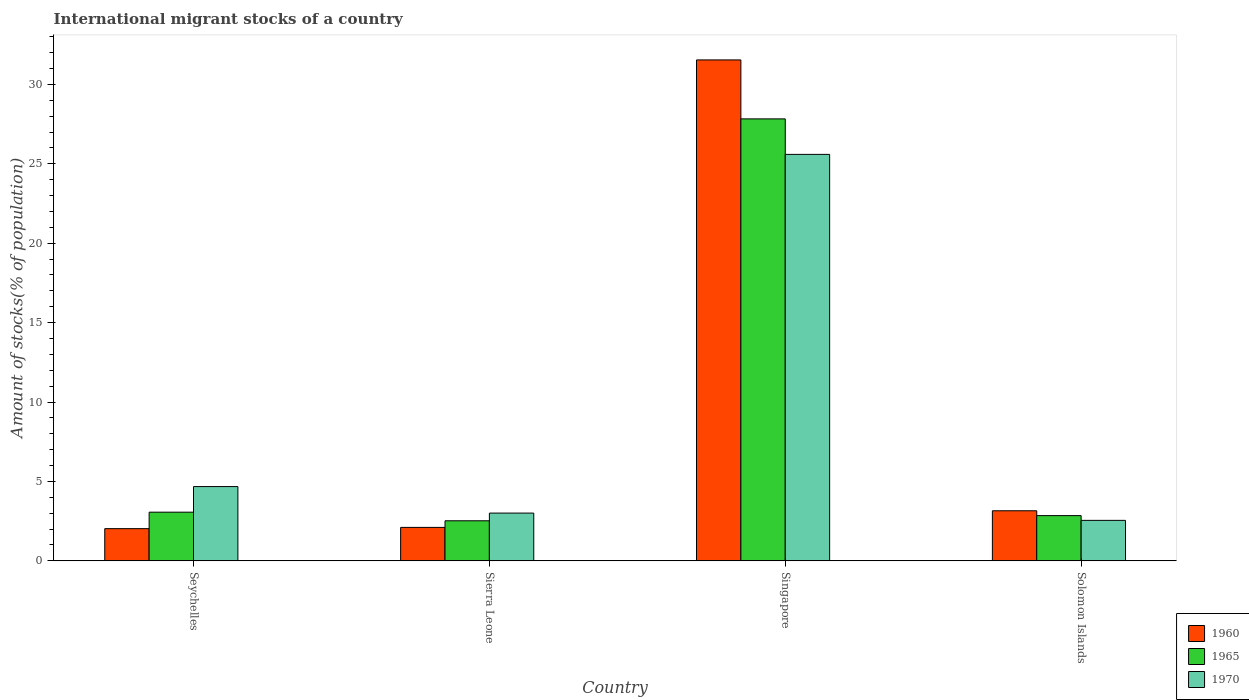How many different coloured bars are there?
Provide a short and direct response. 3. Are the number of bars per tick equal to the number of legend labels?
Keep it short and to the point. Yes. How many bars are there on the 3rd tick from the left?
Ensure brevity in your answer.  3. How many bars are there on the 4th tick from the right?
Keep it short and to the point. 3. What is the label of the 2nd group of bars from the left?
Ensure brevity in your answer.  Sierra Leone. What is the amount of stocks in in 1965 in Solomon Islands?
Provide a succinct answer. 2.85. Across all countries, what is the maximum amount of stocks in in 1970?
Ensure brevity in your answer.  25.59. Across all countries, what is the minimum amount of stocks in in 1970?
Your answer should be compact. 2.55. In which country was the amount of stocks in in 1965 maximum?
Your response must be concise. Singapore. In which country was the amount of stocks in in 1970 minimum?
Provide a succinct answer. Solomon Islands. What is the total amount of stocks in in 1960 in the graph?
Offer a very short reply. 38.82. What is the difference between the amount of stocks in in 1965 in Sierra Leone and that in Singapore?
Provide a succinct answer. -25.31. What is the difference between the amount of stocks in in 1970 in Solomon Islands and the amount of stocks in in 1965 in Singapore?
Make the answer very short. -25.28. What is the average amount of stocks in in 1970 per country?
Provide a short and direct response. 8.95. What is the difference between the amount of stocks in of/in 1960 and amount of stocks in of/in 1970 in Solomon Islands?
Provide a short and direct response. 0.6. What is the ratio of the amount of stocks in in 1970 in Singapore to that in Solomon Islands?
Your answer should be very brief. 10.04. What is the difference between the highest and the second highest amount of stocks in in 1970?
Keep it short and to the point. 22.58. What is the difference between the highest and the lowest amount of stocks in in 1965?
Keep it short and to the point. 25.31. Is it the case that in every country, the sum of the amount of stocks in in 1965 and amount of stocks in in 1960 is greater than the amount of stocks in in 1970?
Make the answer very short. Yes. What is the difference between two consecutive major ticks on the Y-axis?
Offer a terse response. 5. Are the values on the major ticks of Y-axis written in scientific E-notation?
Your answer should be very brief. No. Does the graph contain any zero values?
Offer a very short reply. No. How many legend labels are there?
Your response must be concise. 3. How are the legend labels stacked?
Make the answer very short. Vertical. What is the title of the graph?
Provide a succinct answer. International migrant stocks of a country. What is the label or title of the Y-axis?
Your answer should be very brief. Amount of stocks(% of population). What is the Amount of stocks(% of population) of 1960 in Seychelles?
Provide a succinct answer. 2.03. What is the Amount of stocks(% of population) in 1965 in Seychelles?
Your answer should be very brief. 3.06. What is the Amount of stocks(% of population) in 1970 in Seychelles?
Your answer should be very brief. 4.68. What is the Amount of stocks(% of population) of 1960 in Sierra Leone?
Keep it short and to the point. 2.1. What is the Amount of stocks(% of population) in 1965 in Sierra Leone?
Give a very brief answer. 2.52. What is the Amount of stocks(% of population) in 1970 in Sierra Leone?
Offer a very short reply. 3.01. What is the Amount of stocks(% of population) in 1960 in Singapore?
Your answer should be very brief. 31.54. What is the Amount of stocks(% of population) in 1965 in Singapore?
Ensure brevity in your answer.  27.83. What is the Amount of stocks(% of population) of 1970 in Singapore?
Offer a terse response. 25.59. What is the Amount of stocks(% of population) of 1960 in Solomon Islands?
Offer a terse response. 3.15. What is the Amount of stocks(% of population) in 1965 in Solomon Islands?
Offer a terse response. 2.85. What is the Amount of stocks(% of population) of 1970 in Solomon Islands?
Your answer should be very brief. 2.55. Across all countries, what is the maximum Amount of stocks(% of population) of 1960?
Make the answer very short. 31.54. Across all countries, what is the maximum Amount of stocks(% of population) in 1965?
Your response must be concise. 27.83. Across all countries, what is the maximum Amount of stocks(% of population) of 1970?
Offer a terse response. 25.59. Across all countries, what is the minimum Amount of stocks(% of population) in 1960?
Your answer should be compact. 2.03. Across all countries, what is the minimum Amount of stocks(% of population) in 1965?
Keep it short and to the point. 2.52. Across all countries, what is the minimum Amount of stocks(% of population) of 1970?
Your answer should be very brief. 2.55. What is the total Amount of stocks(% of population) in 1960 in the graph?
Keep it short and to the point. 38.82. What is the total Amount of stocks(% of population) of 1965 in the graph?
Provide a succinct answer. 36.26. What is the total Amount of stocks(% of population) in 1970 in the graph?
Give a very brief answer. 35.82. What is the difference between the Amount of stocks(% of population) of 1960 in Seychelles and that in Sierra Leone?
Offer a terse response. -0.08. What is the difference between the Amount of stocks(% of population) of 1965 in Seychelles and that in Sierra Leone?
Offer a very short reply. 0.54. What is the difference between the Amount of stocks(% of population) in 1970 in Seychelles and that in Sierra Leone?
Offer a terse response. 1.67. What is the difference between the Amount of stocks(% of population) in 1960 in Seychelles and that in Singapore?
Offer a very short reply. -29.51. What is the difference between the Amount of stocks(% of population) in 1965 in Seychelles and that in Singapore?
Make the answer very short. -24.76. What is the difference between the Amount of stocks(% of population) of 1970 in Seychelles and that in Singapore?
Provide a short and direct response. -20.91. What is the difference between the Amount of stocks(% of population) of 1960 in Seychelles and that in Solomon Islands?
Your response must be concise. -1.13. What is the difference between the Amount of stocks(% of population) of 1965 in Seychelles and that in Solomon Islands?
Your response must be concise. 0.22. What is the difference between the Amount of stocks(% of population) of 1970 in Seychelles and that in Solomon Islands?
Your answer should be very brief. 2.13. What is the difference between the Amount of stocks(% of population) in 1960 in Sierra Leone and that in Singapore?
Provide a succinct answer. -29.43. What is the difference between the Amount of stocks(% of population) in 1965 in Sierra Leone and that in Singapore?
Offer a very short reply. -25.31. What is the difference between the Amount of stocks(% of population) of 1970 in Sierra Leone and that in Singapore?
Offer a very short reply. -22.58. What is the difference between the Amount of stocks(% of population) in 1960 in Sierra Leone and that in Solomon Islands?
Give a very brief answer. -1.05. What is the difference between the Amount of stocks(% of population) in 1965 in Sierra Leone and that in Solomon Islands?
Keep it short and to the point. -0.33. What is the difference between the Amount of stocks(% of population) in 1970 in Sierra Leone and that in Solomon Islands?
Offer a terse response. 0.46. What is the difference between the Amount of stocks(% of population) of 1960 in Singapore and that in Solomon Islands?
Provide a succinct answer. 28.39. What is the difference between the Amount of stocks(% of population) in 1965 in Singapore and that in Solomon Islands?
Provide a succinct answer. 24.98. What is the difference between the Amount of stocks(% of population) of 1970 in Singapore and that in Solomon Islands?
Offer a terse response. 23.04. What is the difference between the Amount of stocks(% of population) of 1960 in Seychelles and the Amount of stocks(% of population) of 1965 in Sierra Leone?
Provide a short and direct response. -0.49. What is the difference between the Amount of stocks(% of population) of 1960 in Seychelles and the Amount of stocks(% of population) of 1970 in Sierra Leone?
Ensure brevity in your answer.  -0.98. What is the difference between the Amount of stocks(% of population) in 1965 in Seychelles and the Amount of stocks(% of population) in 1970 in Sierra Leone?
Your answer should be compact. 0.06. What is the difference between the Amount of stocks(% of population) in 1960 in Seychelles and the Amount of stocks(% of population) in 1965 in Singapore?
Offer a very short reply. -25.8. What is the difference between the Amount of stocks(% of population) of 1960 in Seychelles and the Amount of stocks(% of population) of 1970 in Singapore?
Give a very brief answer. -23.56. What is the difference between the Amount of stocks(% of population) in 1965 in Seychelles and the Amount of stocks(% of population) in 1970 in Singapore?
Provide a short and direct response. -22.53. What is the difference between the Amount of stocks(% of population) in 1960 in Seychelles and the Amount of stocks(% of population) in 1965 in Solomon Islands?
Offer a terse response. -0.82. What is the difference between the Amount of stocks(% of population) of 1960 in Seychelles and the Amount of stocks(% of population) of 1970 in Solomon Islands?
Your response must be concise. -0.52. What is the difference between the Amount of stocks(% of population) in 1965 in Seychelles and the Amount of stocks(% of population) in 1970 in Solomon Islands?
Provide a short and direct response. 0.52. What is the difference between the Amount of stocks(% of population) of 1960 in Sierra Leone and the Amount of stocks(% of population) of 1965 in Singapore?
Your answer should be very brief. -25.72. What is the difference between the Amount of stocks(% of population) in 1960 in Sierra Leone and the Amount of stocks(% of population) in 1970 in Singapore?
Keep it short and to the point. -23.49. What is the difference between the Amount of stocks(% of population) of 1965 in Sierra Leone and the Amount of stocks(% of population) of 1970 in Singapore?
Offer a very short reply. -23.07. What is the difference between the Amount of stocks(% of population) in 1960 in Sierra Leone and the Amount of stocks(% of population) in 1965 in Solomon Islands?
Provide a succinct answer. -0.74. What is the difference between the Amount of stocks(% of population) in 1960 in Sierra Leone and the Amount of stocks(% of population) in 1970 in Solomon Islands?
Make the answer very short. -0.44. What is the difference between the Amount of stocks(% of population) in 1965 in Sierra Leone and the Amount of stocks(% of population) in 1970 in Solomon Islands?
Offer a terse response. -0.03. What is the difference between the Amount of stocks(% of population) of 1960 in Singapore and the Amount of stocks(% of population) of 1965 in Solomon Islands?
Provide a succinct answer. 28.69. What is the difference between the Amount of stocks(% of population) in 1960 in Singapore and the Amount of stocks(% of population) in 1970 in Solomon Islands?
Provide a succinct answer. 28.99. What is the difference between the Amount of stocks(% of population) in 1965 in Singapore and the Amount of stocks(% of population) in 1970 in Solomon Islands?
Offer a terse response. 25.28. What is the average Amount of stocks(% of population) in 1960 per country?
Give a very brief answer. 9.71. What is the average Amount of stocks(% of population) of 1965 per country?
Provide a short and direct response. 9.06. What is the average Amount of stocks(% of population) of 1970 per country?
Make the answer very short. 8.95. What is the difference between the Amount of stocks(% of population) of 1960 and Amount of stocks(% of population) of 1965 in Seychelles?
Your answer should be very brief. -1.04. What is the difference between the Amount of stocks(% of population) of 1960 and Amount of stocks(% of population) of 1970 in Seychelles?
Your answer should be compact. -2.65. What is the difference between the Amount of stocks(% of population) of 1965 and Amount of stocks(% of population) of 1970 in Seychelles?
Your response must be concise. -1.61. What is the difference between the Amount of stocks(% of population) of 1960 and Amount of stocks(% of population) of 1965 in Sierra Leone?
Provide a short and direct response. -0.42. What is the difference between the Amount of stocks(% of population) of 1960 and Amount of stocks(% of population) of 1970 in Sierra Leone?
Ensure brevity in your answer.  -0.9. What is the difference between the Amount of stocks(% of population) in 1965 and Amount of stocks(% of population) in 1970 in Sierra Leone?
Your answer should be very brief. -0.49. What is the difference between the Amount of stocks(% of population) in 1960 and Amount of stocks(% of population) in 1965 in Singapore?
Provide a succinct answer. 3.71. What is the difference between the Amount of stocks(% of population) of 1960 and Amount of stocks(% of population) of 1970 in Singapore?
Offer a very short reply. 5.95. What is the difference between the Amount of stocks(% of population) in 1965 and Amount of stocks(% of population) in 1970 in Singapore?
Offer a very short reply. 2.24. What is the difference between the Amount of stocks(% of population) of 1960 and Amount of stocks(% of population) of 1965 in Solomon Islands?
Give a very brief answer. 0.31. What is the difference between the Amount of stocks(% of population) of 1960 and Amount of stocks(% of population) of 1970 in Solomon Islands?
Your response must be concise. 0.6. What is the difference between the Amount of stocks(% of population) in 1965 and Amount of stocks(% of population) in 1970 in Solomon Islands?
Your answer should be very brief. 0.3. What is the ratio of the Amount of stocks(% of population) in 1960 in Seychelles to that in Sierra Leone?
Your answer should be very brief. 0.96. What is the ratio of the Amount of stocks(% of population) of 1965 in Seychelles to that in Sierra Leone?
Make the answer very short. 1.22. What is the ratio of the Amount of stocks(% of population) of 1970 in Seychelles to that in Sierra Leone?
Your answer should be compact. 1.56. What is the ratio of the Amount of stocks(% of population) in 1960 in Seychelles to that in Singapore?
Provide a short and direct response. 0.06. What is the ratio of the Amount of stocks(% of population) of 1965 in Seychelles to that in Singapore?
Provide a succinct answer. 0.11. What is the ratio of the Amount of stocks(% of population) in 1970 in Seychelles to that in Singapore?
Provide a succinct answer. 0.18. What is the ratio of the Amount of stocks(% of population) of 1960 in Seychelles to that in Solomon Islands?
Offer a very short reply. 0.64. What is the ratio of the Amount of stocks(% of population) of 1965 in Seychelles to that in Solomon Islands?
Your answer should be compact. 1.08. What is the ratio of the Amount of stocks(% of population) of 1970 in Seychelles to that in Solomon Islands?
Provide a short and direct response. 1.83. What is the ratio of the Amount of stocks(% of population) of 1960 in Sierra Leone to that in Singapore?
Your answer should be compact. 0.07. What is the ratio of the Amount of stocks(% of population) in 1965 in Sierra Leone to that in Singapore?
Offer a terse response. 0.09. What is the ratio of the Amount of stocks(% of population) in 1970 in Sierra Leone to that in Singapore?
Your answer should be very brief. 0.12. What is the ratio of the Amount of stocks(% of population) in 1960 in Sierra Leone to that in Solomon Islands?
Your answer should be compact. 0.67. What is the ratio of the Amount of stocks(% of population) of 1965 in Sierra Leone to that in Solomon Islands?
Offer a terse response. 0.89. What is the ratio of the Amount of stocks(% of population) of 1970 in Sierra Leone to that in Solomon Islands?
Ensure brevity in your answer.  1.18. What is the ratio of the Amount of stocks(% of population) in 1960 in Singapore to that in Solomon Islands?
Your answer should be very brief. 10.01. What is the ratio of the Amount of stocks(% of population) of 1965 in Singapore to that in Solomon Islands?
Keep it short and to the point. 9.78. What is the ratio of the Amount of stocks(% of population) of 1970 in Singapore to that in Solomon Islands?
Give a very brief answer. 10.04. What is the difference between the highest and the second highest Amount of stocks(% of population) in 1960?
Your answer should be very brief. 28.39. What is the difference between the highest and the second highest Amount of stocks(% of population) of 1965?
Provide a succinct answer. 24.76. What is the difference between the highest and the second highest Amount of stocks(% of population) of 1970?
Offer a terse response. 20.91. What is the difference between the highest and the lowest Amount of stocks(% of population) in 1960?
Make the answer very short. 29.51. What is the difference between the highest and the lowest Amount of stocks(% of population) in 1965?
Provide a short and direct response. 25.31. What is the difference between the highest and the lowest Amount of stocks(% of population) of 1970?
Your answer should be compact. 23.04. 